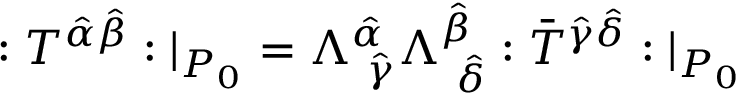<formula> <loc_0><loc_0><loc_500><loc_500>\colon T ^ { \hat { \alpha } \hat { \beta } } \colon | _ { P _ { 0 } } = \Lambda _ { \ \hat { \gamma } } ^ { \hat { \alpha } } \Lambda _ { \ \hat { \delta } } ^ { \hat { \beta } } \colon \bar { T } ^ { \hat { \gamma } \hat { \delta } } \colon | _ { P _ { 0 } }</formula> 